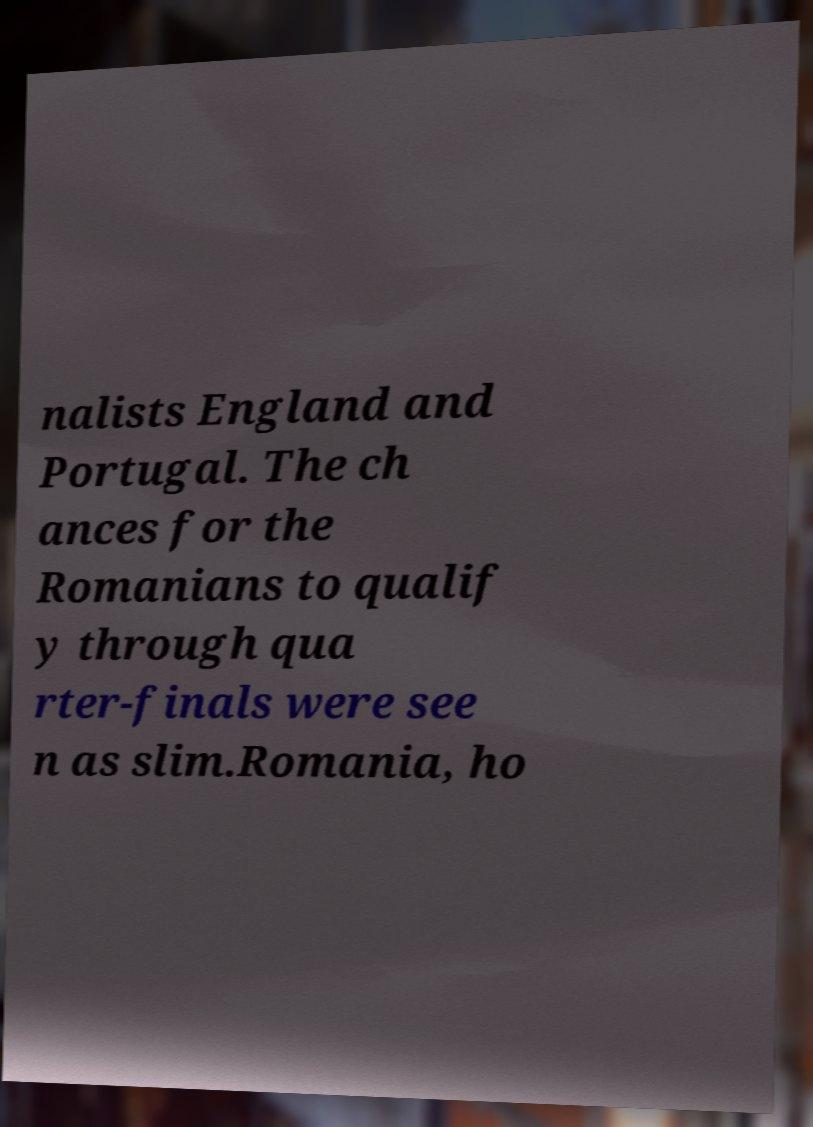Can you read and provide the text displayed in the image?This photo seems to have some interesting text. Can you extract and type it out for me? nalists England and Portugal. The ch ances for the Romanians to qualif y through qua rter-finals were see n as slim.Romania, ho 